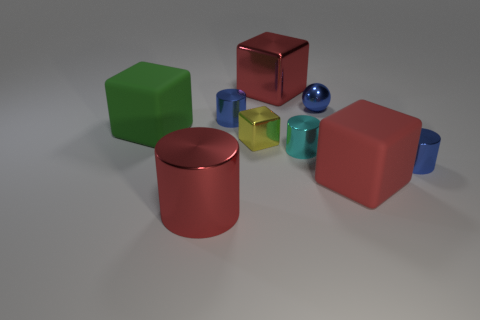Are the objects arranged in a particular pattern? The objects are not arranged in a specific pattern; they appear to be placed randomly across a flat surface. This scattered arrangement provides a casual, unstructured look. 